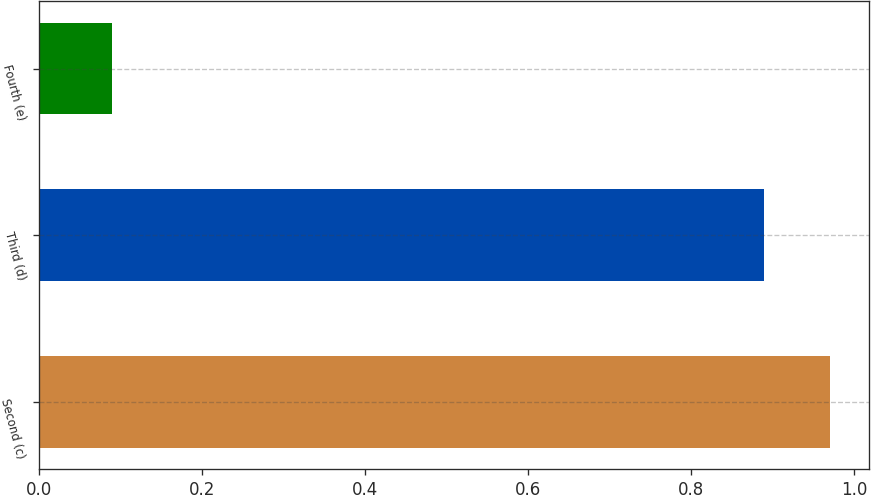Convert chart. <chart><loc_0><loc_0><loc_500><loc_500><bar_chart><fcel>Second (c)<fcel>Third (d)<fcel>Fourth (e)<nl><fcel>0.97<fcel>0.89<fcel>0.09<nl></chart> 